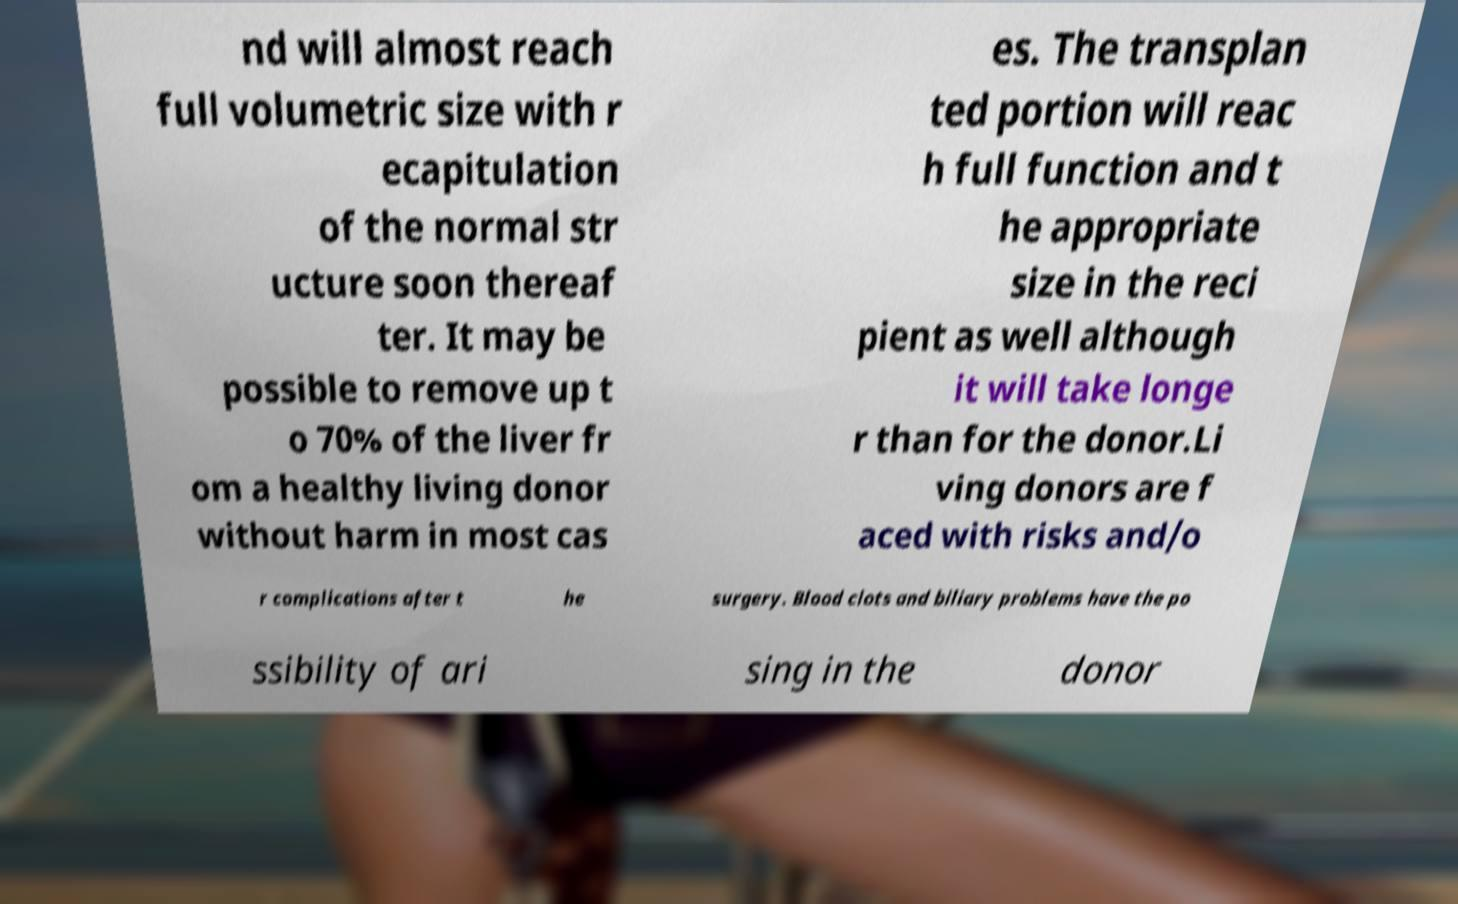Can you read and provide the text displayed in the image?This photo seems to have some interesting text. Can you extract and type it out for me? nd will almost reach full volumetric size with r ecapitulation of the normal str ucture soon thereaf ter. It may be possible to remove up t o 70% of the liver fr om a healthy living donor without harm in most cas es. The transplan ted portion will reac h full function and t he appropriate size in the reci pient as well although it will take longe r than for the donor.Li ving donors are f aced with risks and/o r complications after t he surgery. Blood clots and biliary problems have the po ssibility of ari sing in the donor 